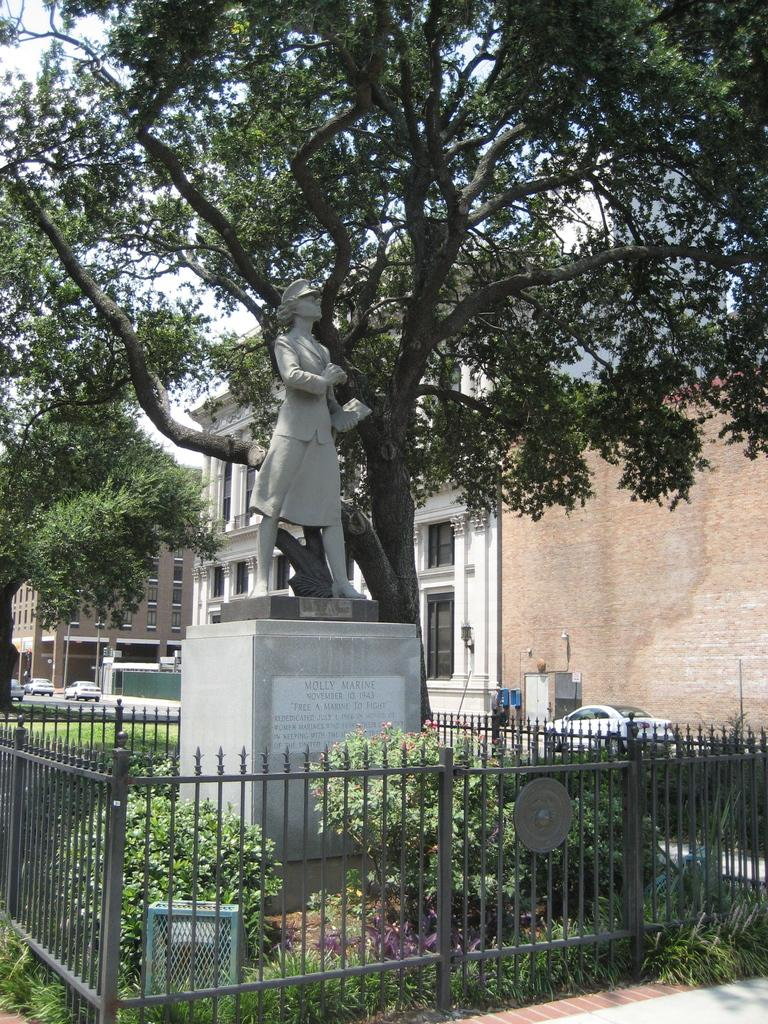<image>
Share a concise interpretation of the image provided. A fenced garden contains a statue of a woman named Molly Marine. 